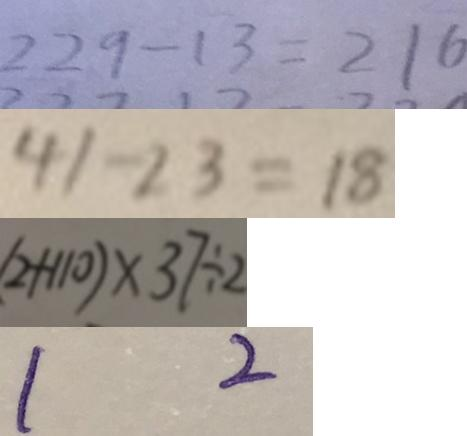<formula> <loc_0><loc_0><loc_500><loc_500>2 2 9 - 1 3 = 2 1 6 
 4 1 - 2 3 = 1 8 
 ( 2 + 1 1 0 ) \times 3 7 \div 2 
 1 2</formula> 